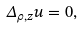Convert formula to latex. <formula><loc_0><loc_0><loc_500><loc_500>\Delta _ { \rho , z } u = 0 ,</formula> 